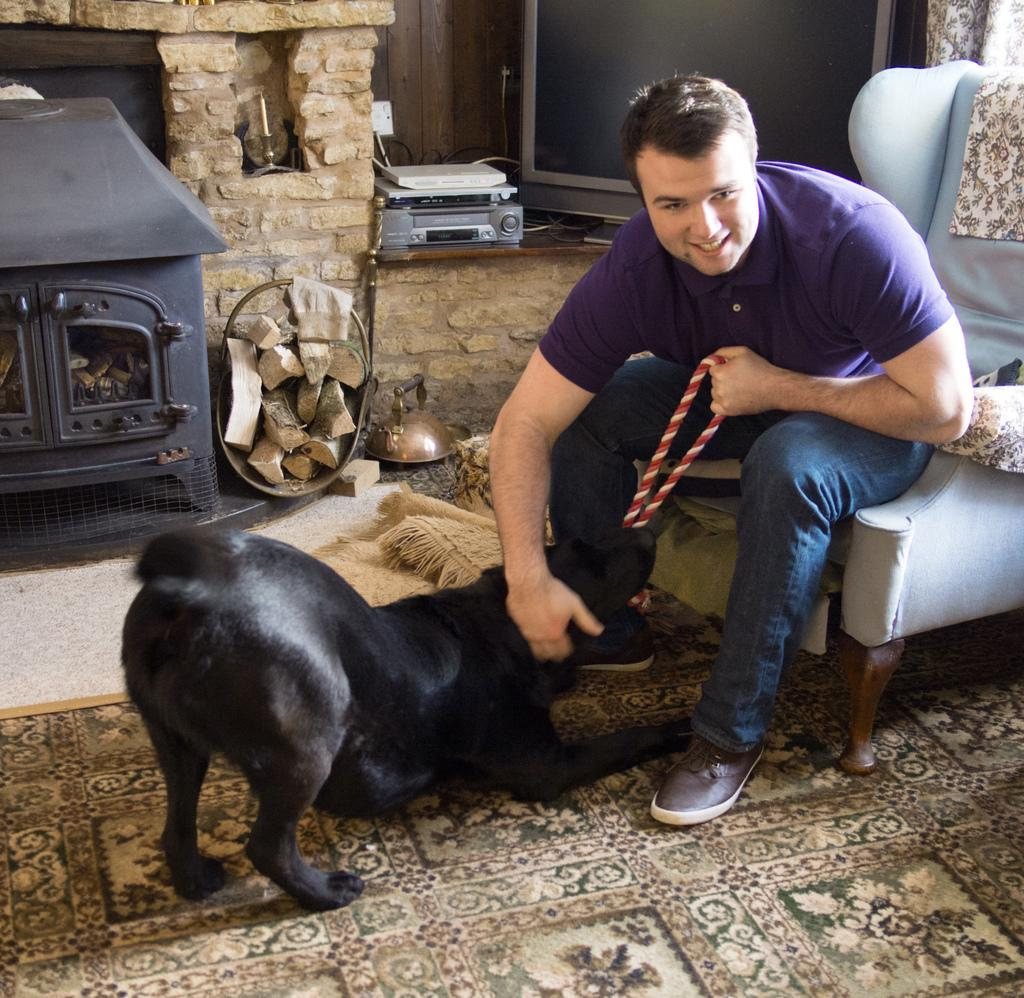What is the man doing in the image? The man is sitting on a chair in the image. What other living creature is present in the image? There is a dog in the image. What can be seen in the background of the image? There is a wall in the background of the image. What electronic device is visible in the image? There is a television in the image. What type of surface is visible beneath the man and the dog? There is a floor visible in the image. What type of payment is being made for the town in the image? There is no mention of payment or a town in the image; it features a man sitting on a chair with a dog nearby. 